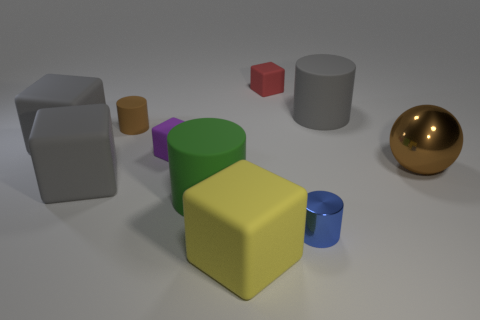Subtract all big gray matte blocks. How many blocks are left? 3 Subtract all yellow cubes. How many cubes are left? 4 Subtract all cylinders. How many objects are left? 6 Subtract 2 cylinders. How many cylinders are left? 2 Subtract all purple cubes. Subtract all green balls. How many cubes are left? 4 Subtract all gray cylinders. How many cyan cubes are left? 0 Subtract all big gray rubber cylinders. Subtract all big gray matte cubes. How many objects are left? 7 Add 3 large brown shiny objects. How many large brown shiny objects are left? 4 Add 5 large gray blocks. How many large gray blocks exist? 7 Subtract 0 green cubes. How many objects are left? 10 